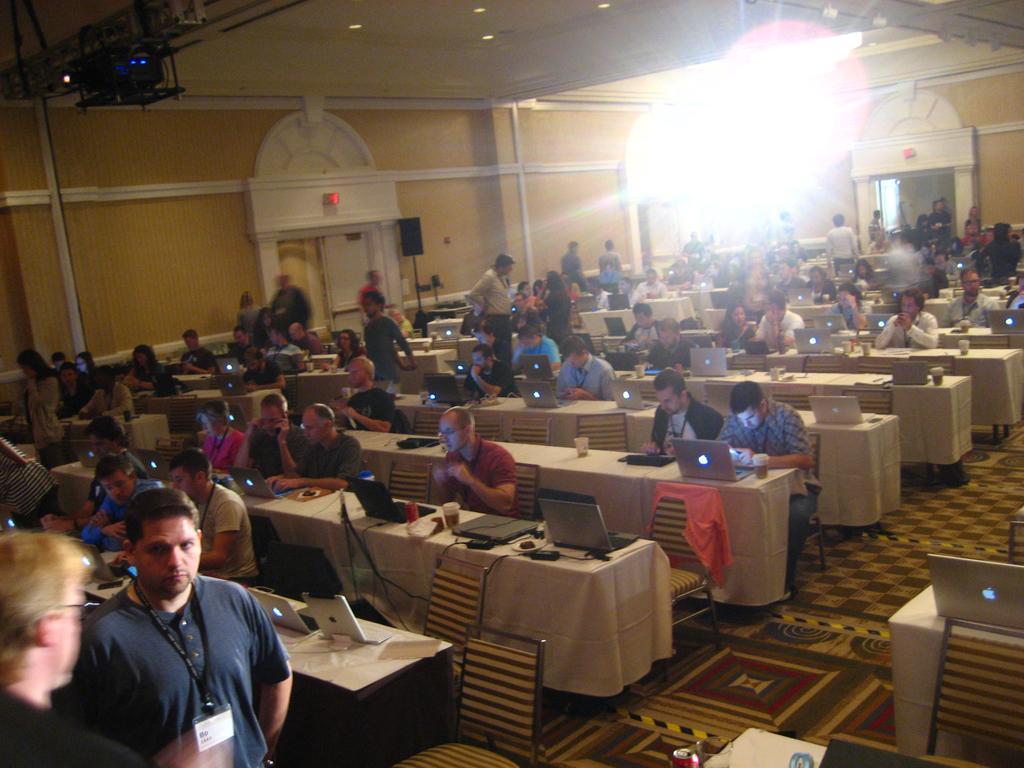Please provide a concise description of this image. Here a group of people are working by sitting on the chairs on the left side there is a person standing. 